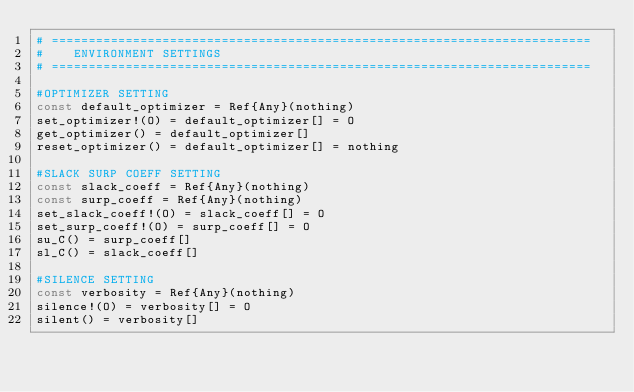<code> <loc_0><loc_0><loc_500><loc_500><_Julia_># =========================================================================
#    ENVIRONMENT SETTINGS
# =========================================================================

#OPTIMIZER SETTING
const default_optimizer = Ref{Any}(nothing)
set_optimizer!(O) = default_optimizer[] = O
get_optimizer() = default_optimizer[]
reset_optimizer() = default_optimizer[] = nothing

#SLACK SURP COEFF SETTING
const slack_coeff = Ref{Any}(nothing)
const surp_coeff = Ref{Any}(nothing)
set_slack_coeff!(O) = slack_coeff[] = O
set_surp_coeff!(O) = surp_coeff[] = O
su_C() = surp_coeff[]
sl_C() = slack_coeff[]

#SILENCE SETTING
const verbosity = Ref{Any}(nothing)
silence!(O) = verbosity[] = O
silent() = verbosity[]
</code> 